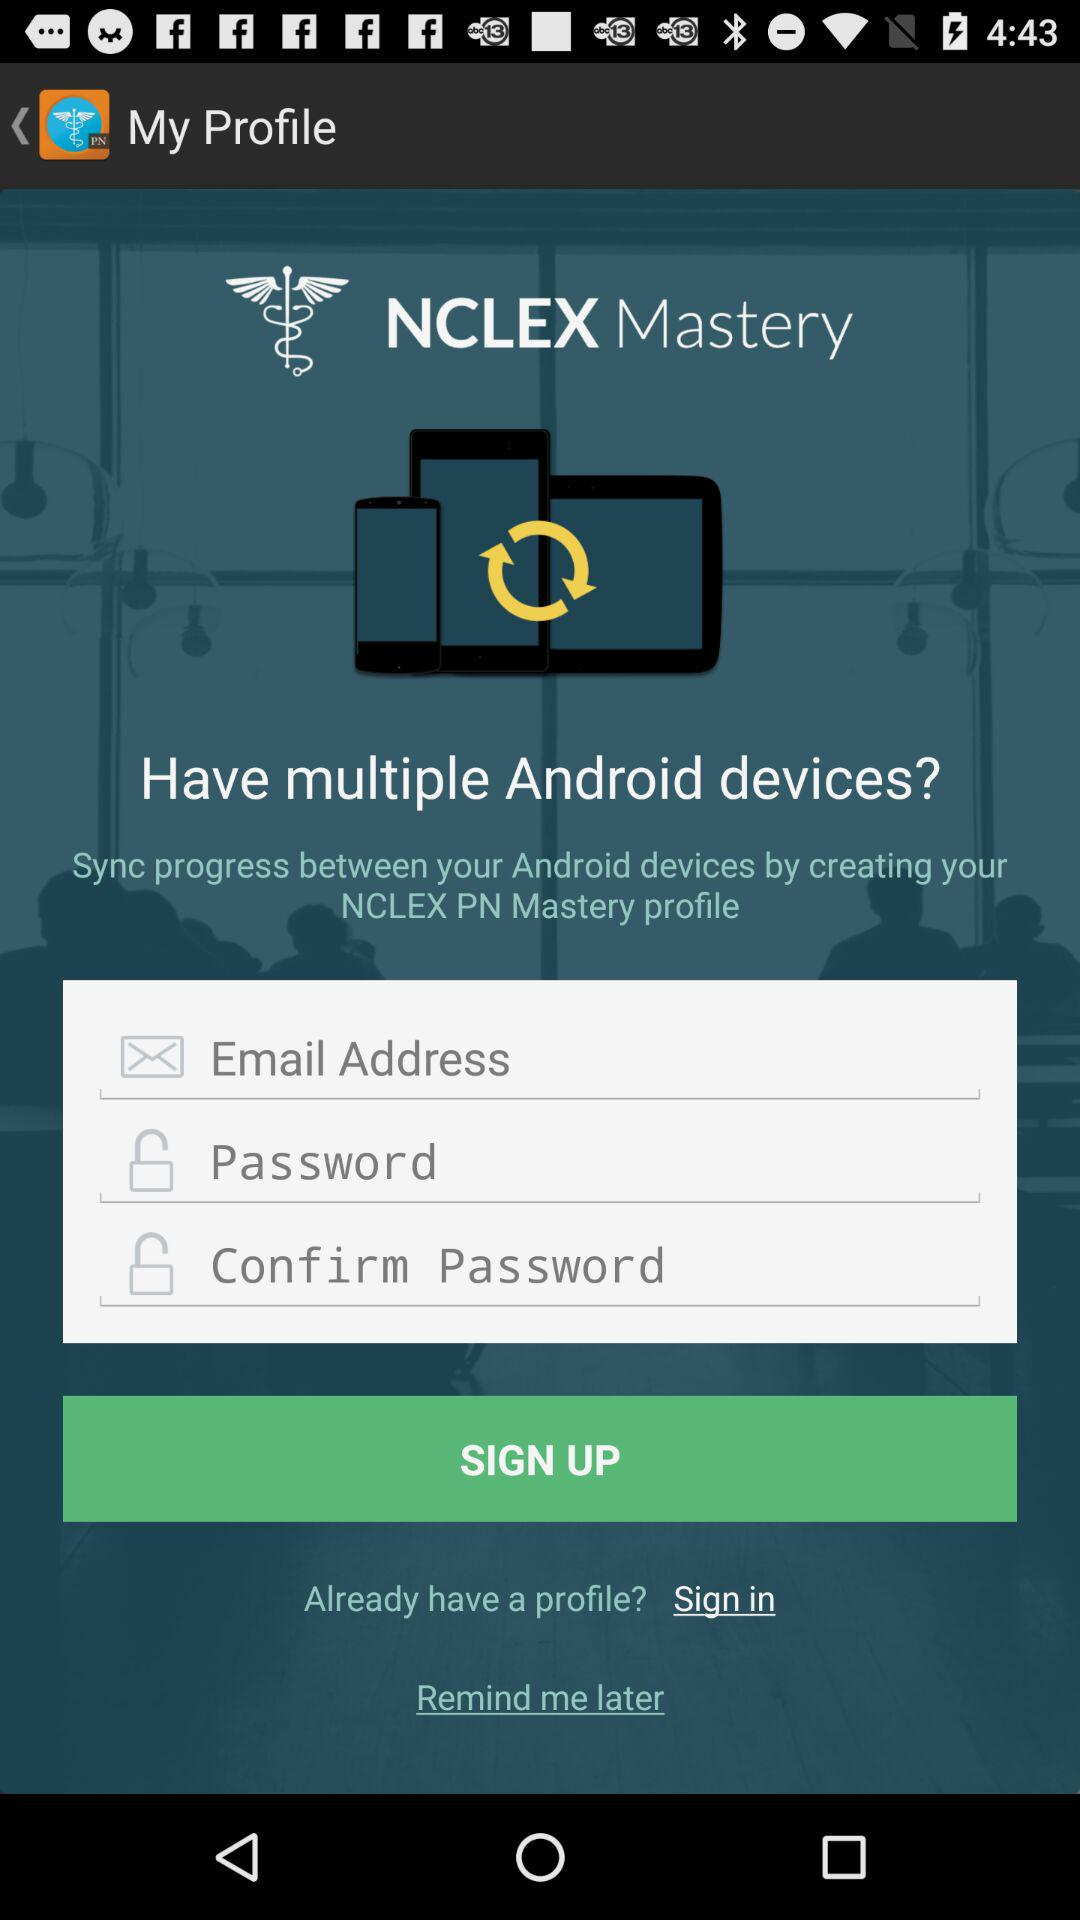What is the name of the application? The application name is "NCLEX Mastery". 